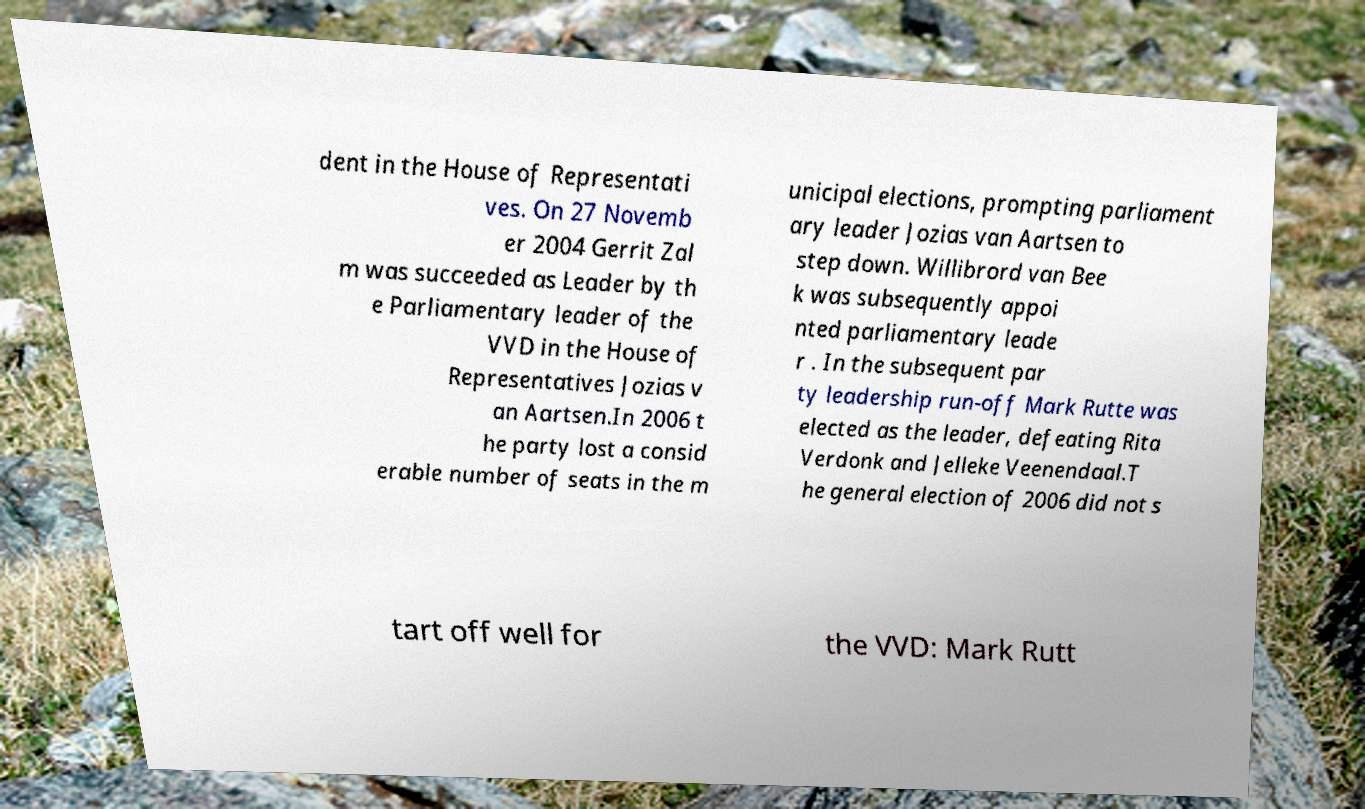Can you read and provide the text displayed in the image?This photo seems to have some interesting text. Can you extract and type it out for me? dent in the House of Representati ves. On 27 Novemb er 2004 Gerrit Zal m was succeeded as Leader by th e Parliamentary leader of the VVD in the House of Representatives Jozias v an Aartsen.In 2006 t he party lost a consid erable number of seats in the m unicipal elections, prompting parliament ary leader Jozias van Aartsen to step down. Willibrord van Bee k was subsequently appoi nted parliamentary leade r . In the subsequent par ty leadership run-off Mark Rutte was elected as the leader, defeating Rita Verdonk and Jelleke Veenendaal.T he general election of 2006 did not s tart off well for the VVD: Mark Rutt 